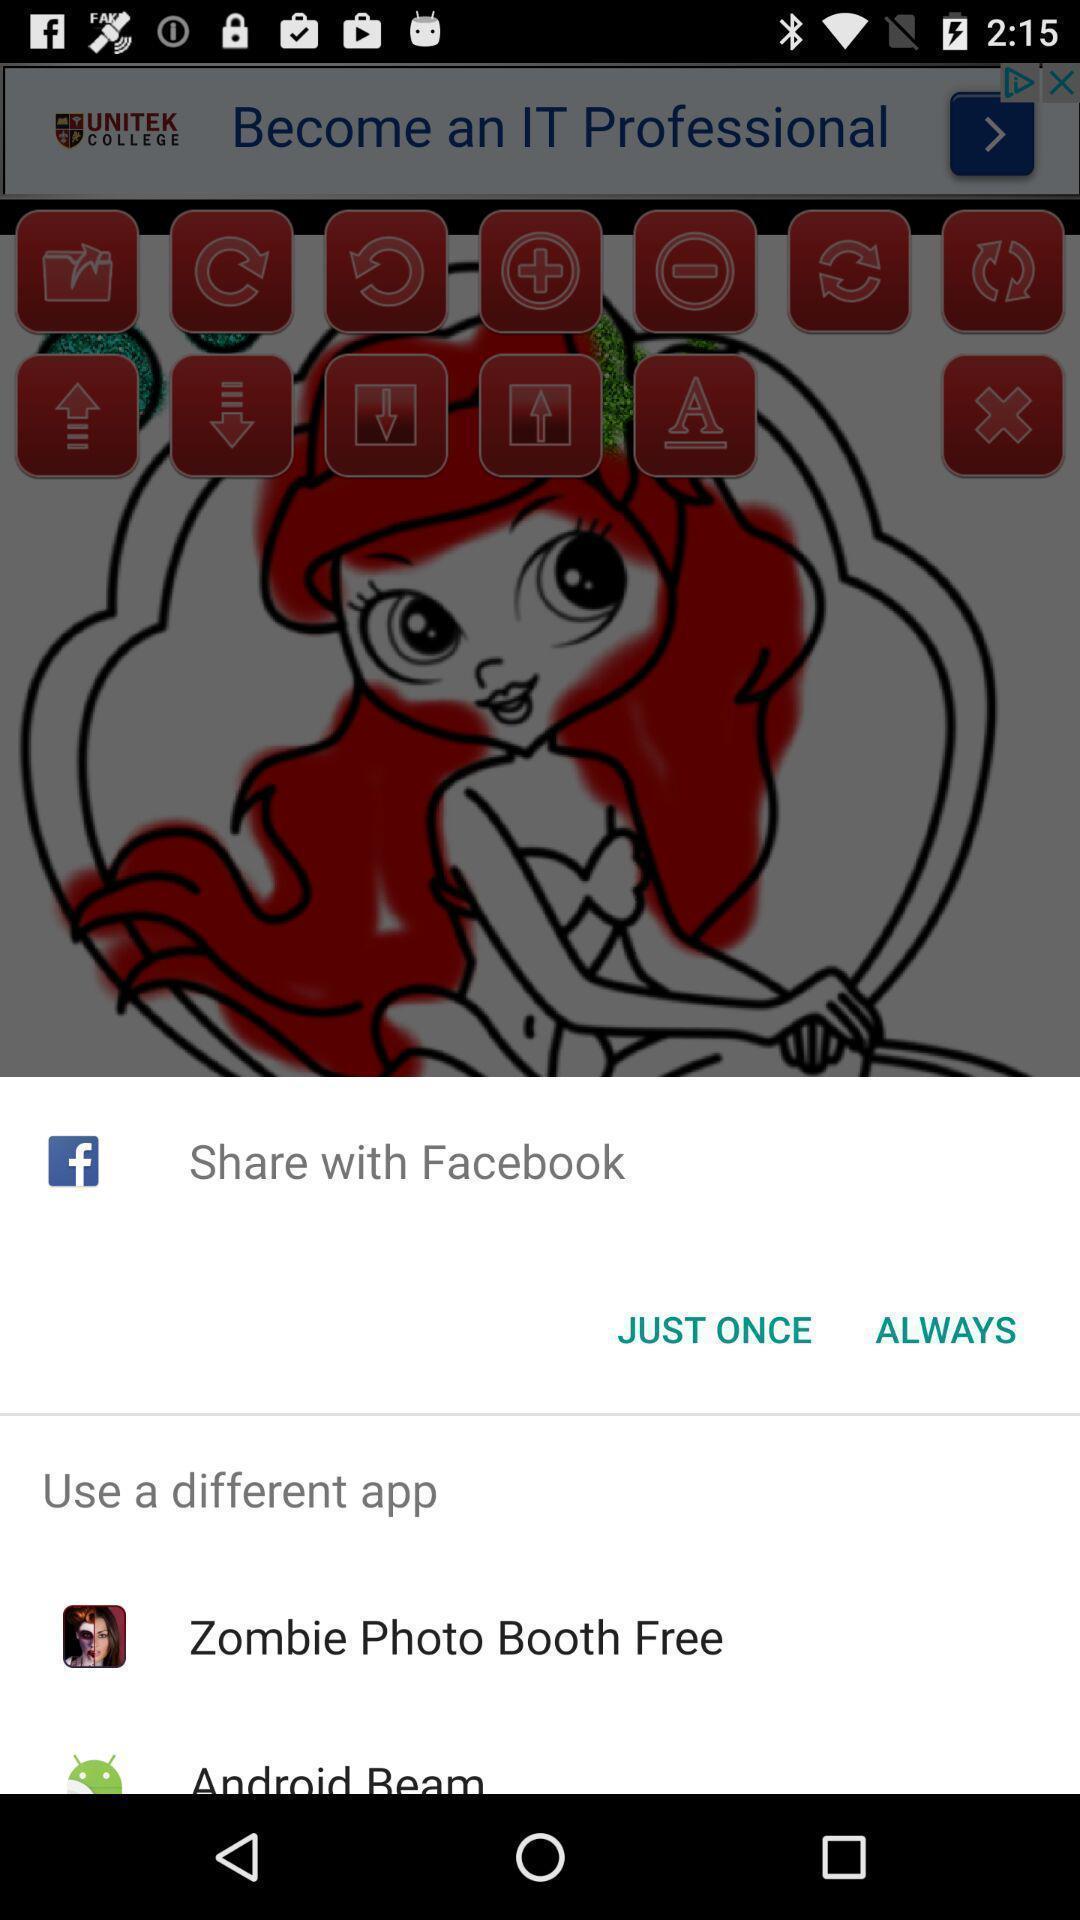Tell me about the visual elements in this screen capture. Pop-up with various sharing options. 